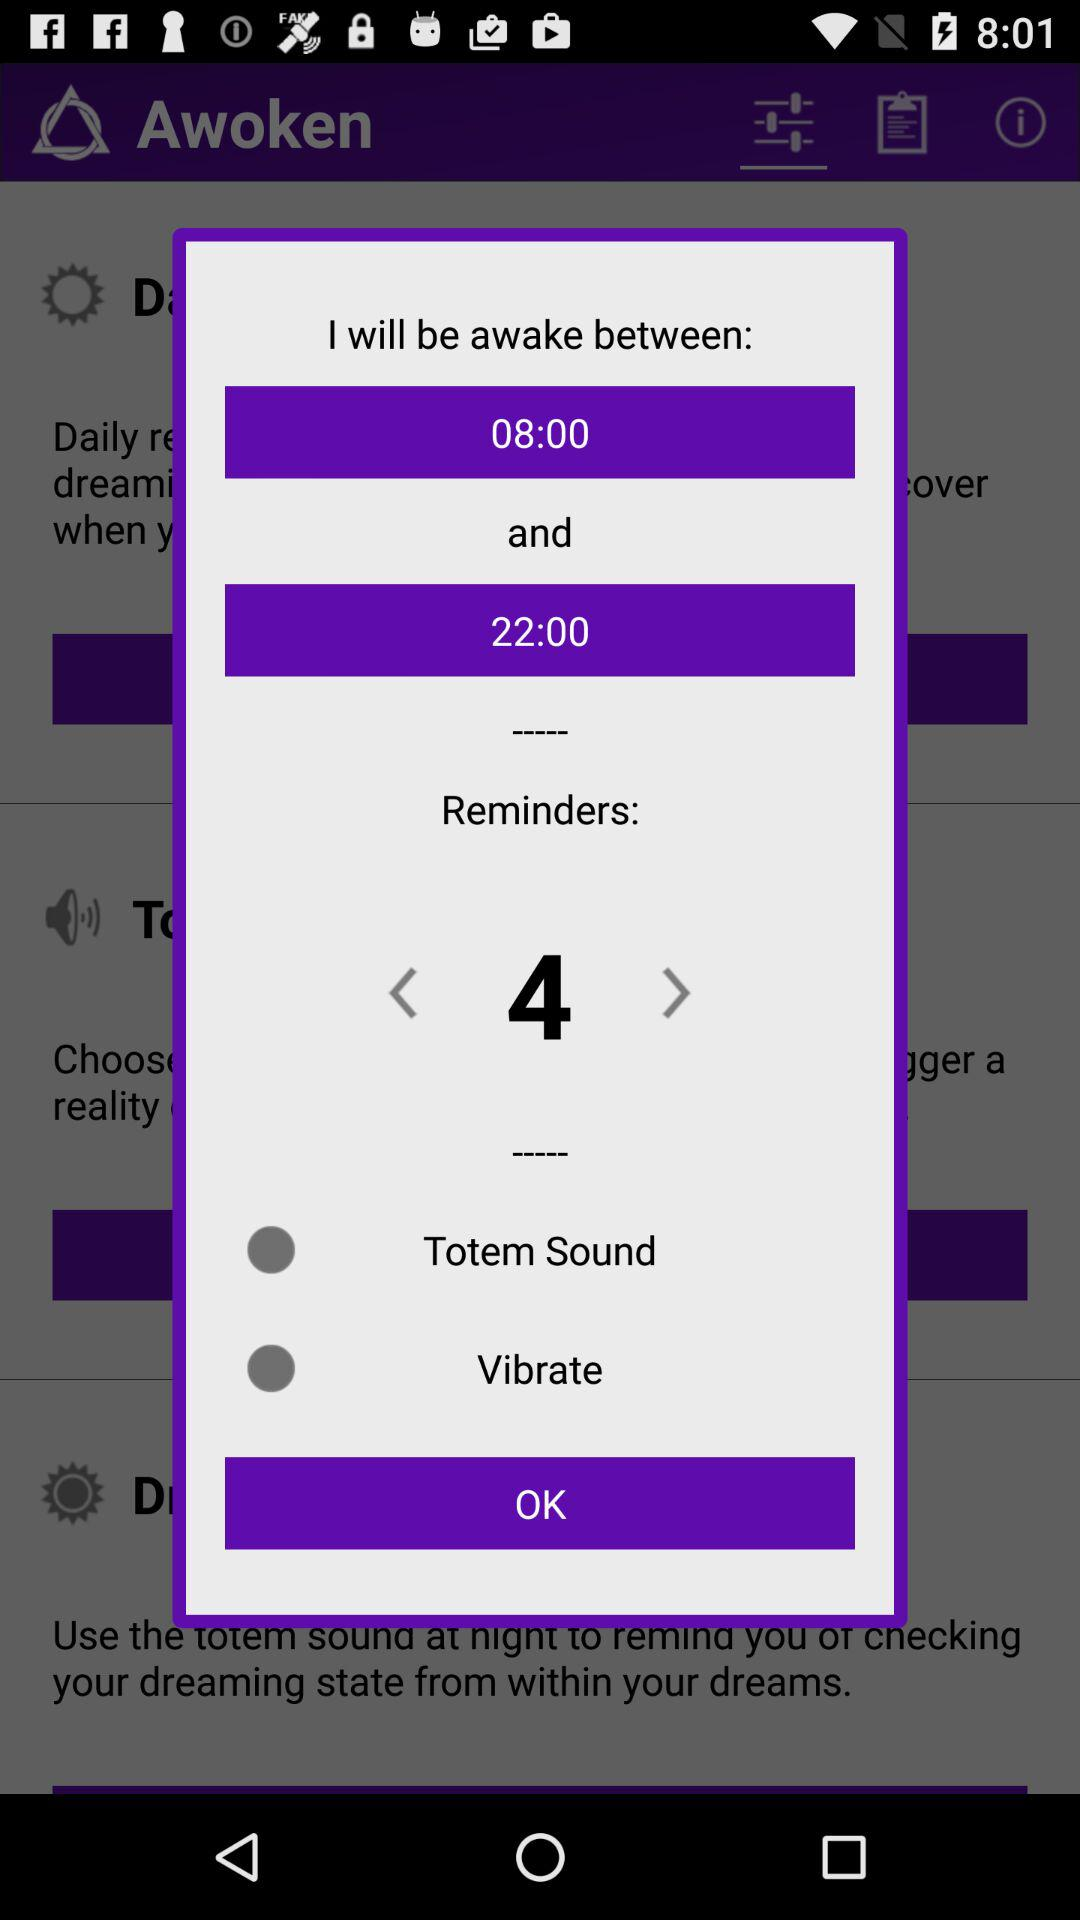Is vibrate option selected?
When the provided information is insufficient, respond with <no answer>. <no answer> 